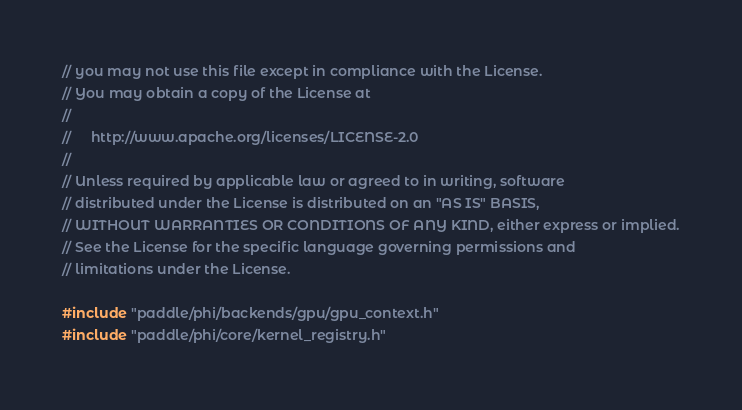Convert code to text. <code><loc_0><loc_0><loc_500><loc_500><_Cuda_>// you may not use this file except in compliance with the License.
// You may obtain a copy of the License at
//
//     http://www.apache.org/licenses/LICENSE-2.0
//
// Unless required by applicable law or agreed to in writing, software
// distributed under the License is distributed on an "AS IS" BASIS,
// WITHOUT WARRANTIES OR CONDITIONS OF ANY KIND, either express or implied.
// See the License for the specific language governing permissions and
// limitations under the License.

#include "paddle/phi/backends/gpu/gpu_context.h"
#include "paddle/phi/core/kernel_registry.h"</code> 